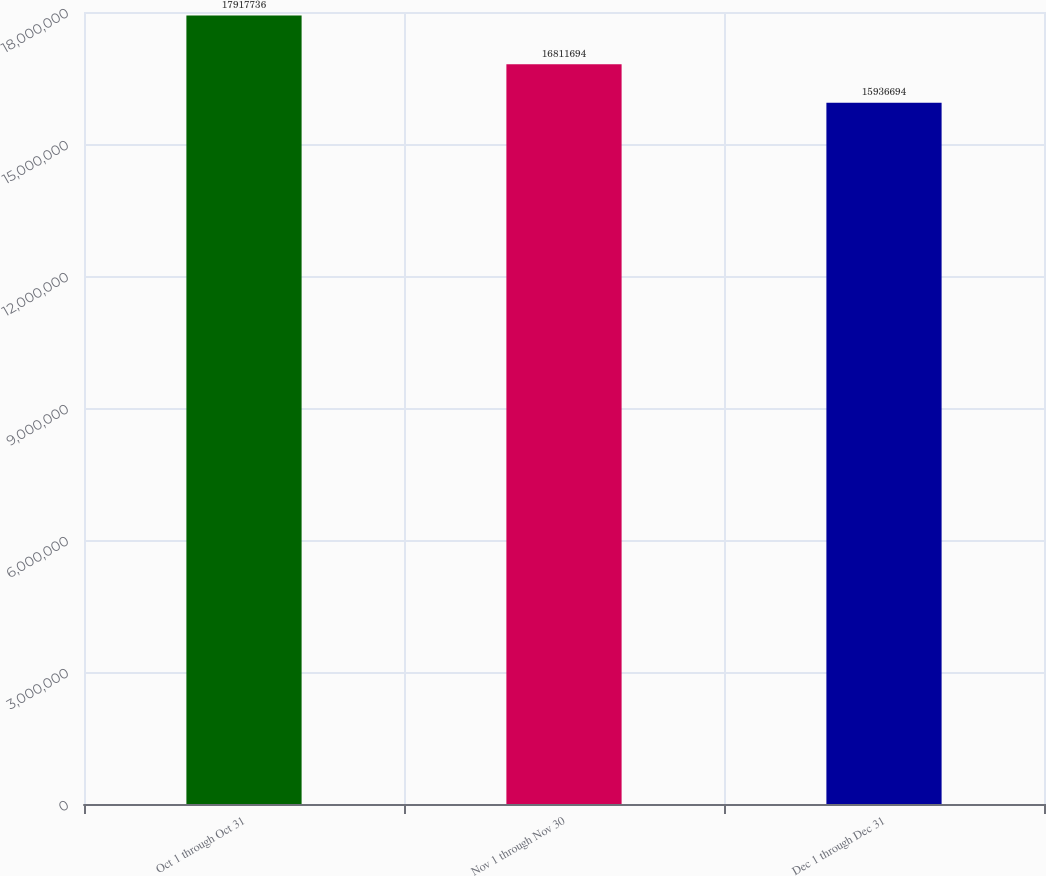<chart> <loc_0><loc_0><loc_500><loc_500><bar_chart><fcel>Oct 1 through Oct 31<fcel>Nov 1 through Nov 30<fcel>Dec 1 through Dec 31<nl><fcel>1.79177e+07<fcel>1.68117e+07<fcel>1.59367e+07<nl></chart> 